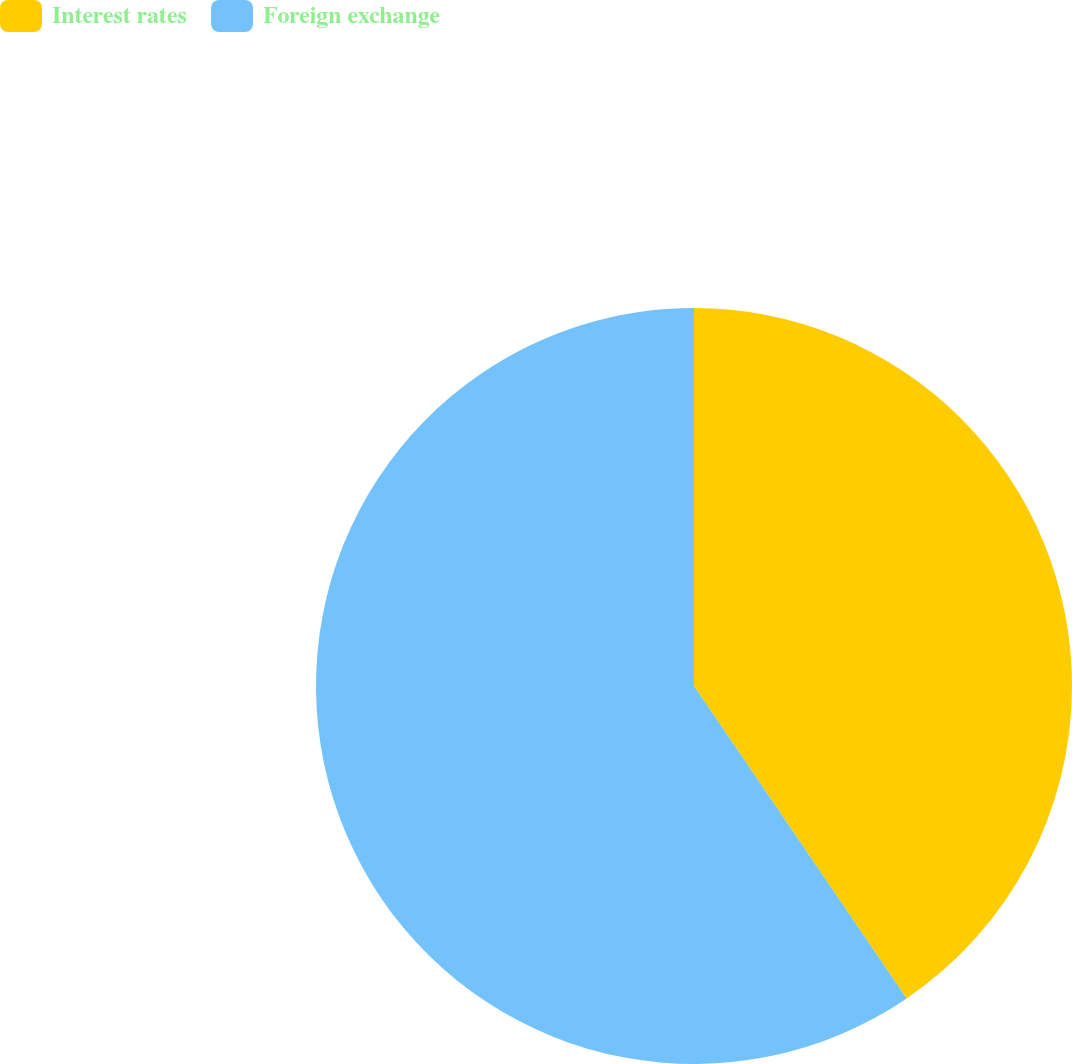Convert chart. <chart><loc_0><loc_0><loc_500><loc_500><pie_chart><fcel>Interest rates<fcel>Foreign exchange<nl><fcel>40.49%<fcel>59.51%<nl></chart> 